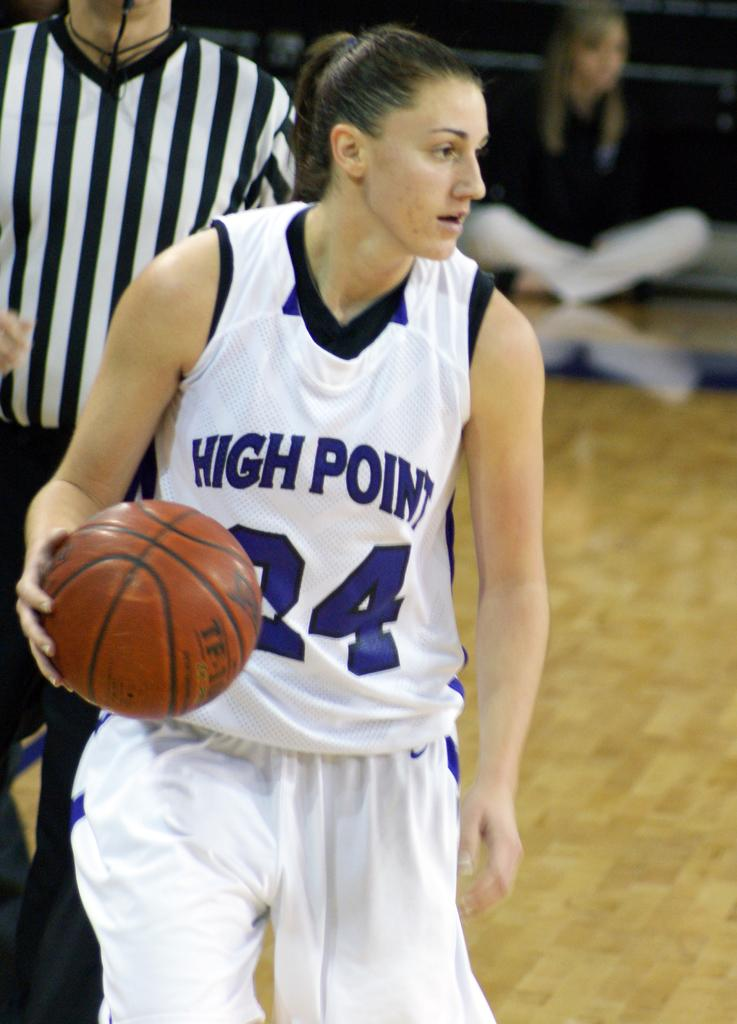<image>
Share a concise interpretation of the image provided. a women playing basketball with the uniform number 24 